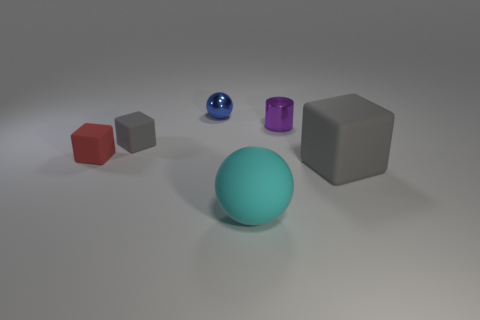Add 2 small purple shiny things. How many objects exist? 8 Subtract all cylinders. How many objects are left? 5 Add 4 blue shiny objects. How many blue shiny objects are left? 5 Add 5 blue things. How many blue things exist? 6 Subtract 0 purple spheres. How many objects are left? 6 Subtract all tiny gray matte things. Subtract all big gray rubber objects. How many objects are left? 4 